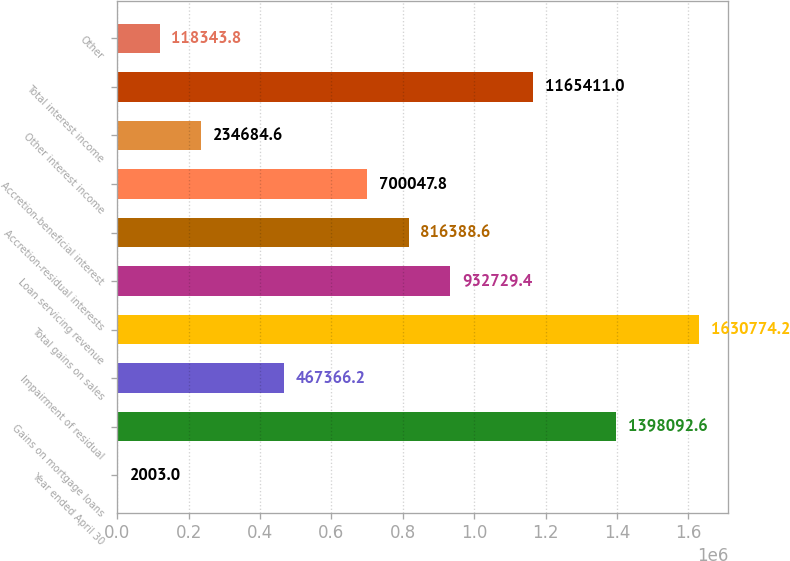Convert chart to OTSL. <chart><loc_0><loc_0><loc_500><loc_500><bar_chart><fcel>Year ended April 30<fcel>Gains on mortgage loans<fcel>Impairment of residual<fcel>Total gains on sales<fcel>Loan servicing revenue<fcel>Accretion-residual interests<fcel>Accretion-beneficial interest<fcel>Other interest income<fcel>Total interest income<fcel>Other<nl><fcel>2003<fcel>1.39809e+06<fcel>467366<fcel>1.63077e+06<fcel>932729<fcel>816389<fcel>700048<fcel>234685<fcel>1.16541e+06<fcel>118344<nl></chart> 